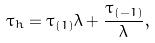<formula> <loc_0><loc_0><loc_500><loc_500>\tau _ { h } = \tau _ { ( 1 ) } \lambda + \frac { \tau _ { ( - 1 ) } } { \lambda } ,</formula> 